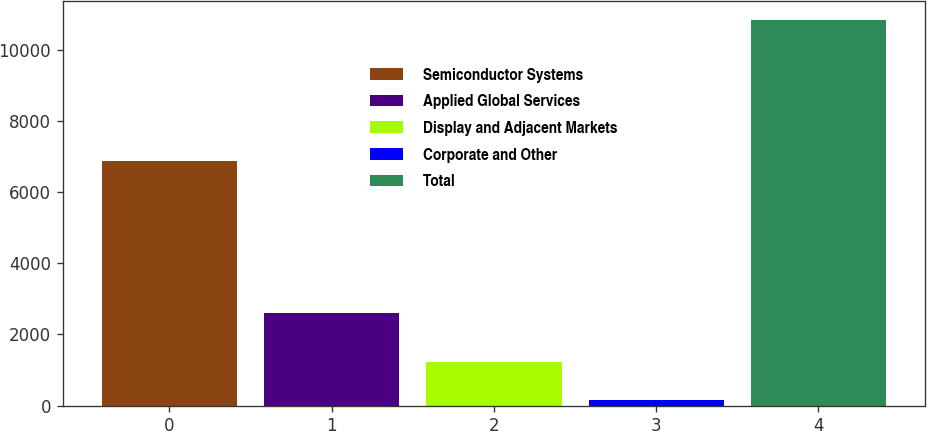<chart> <loc_0><loc_0><loc_500><loc_500><bar_chart><fcel>Semiconductor Systems<fcel>Applied Global Services<fcel>Display and Adjacent Markets<fcel>Corporate and Other<fcel>Total<nl><fcel>6873<fcel>2589<fcel>1223.8<fcel>157<fcel>10825<nl></chart> 